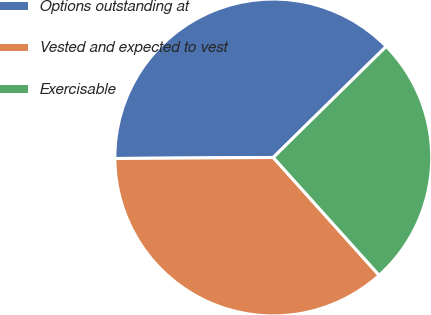Convert chart to OTSL. <chart><loc_0><loc_0><loc_500><loc_500><pie_chart><fcel>Options outstanding at<fcel>Vested and expected to vest<fcel>Exercisable<nl><fcel>37.74%<fcel>36.55%<fcel>25.71%<nl></chart> 